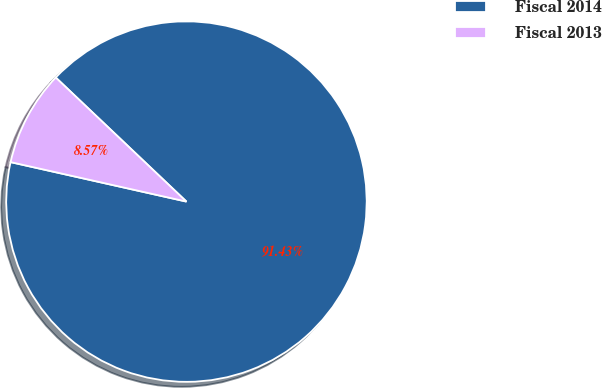Convert chart. <chart><loc_0><loc_0><loc_500><loc_500><pie_chart><fcel>Fiscal 2014<fcel>Fiscal 2013<nl><fcel>91.43%<fcel>8.57%<nl></chart> 